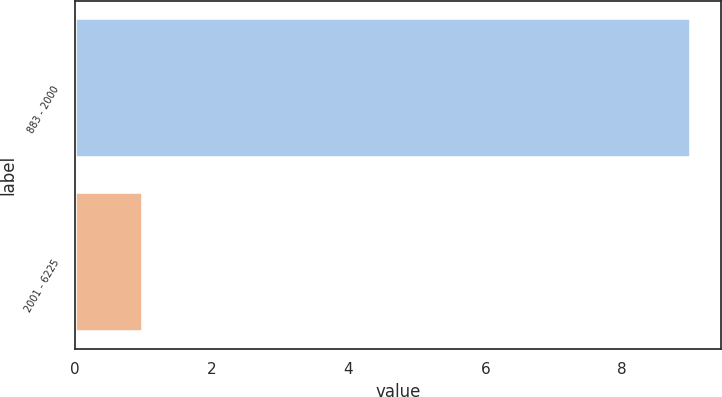Convert chart to OTSL. <chart><loc_0><loc_0><loc_500><loc_500><bar_chart><fcel>883 - 2000<fcel>2001 - 6225<nl><fcel>9<fcel>1<nl></chart> 